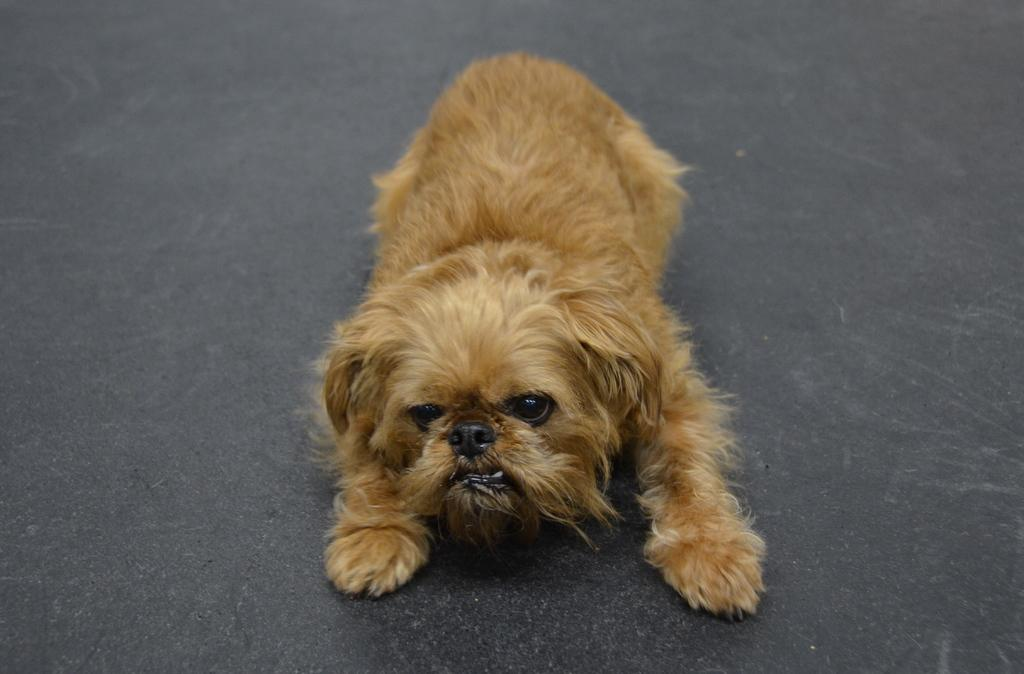What animal can be seen in the image? There is a dog in the image. Where is the dog located? The dog is on the road. What type of canvas is the dog sitting on in the image? There is no canvas present in the image; the dog is sitting on the road. 